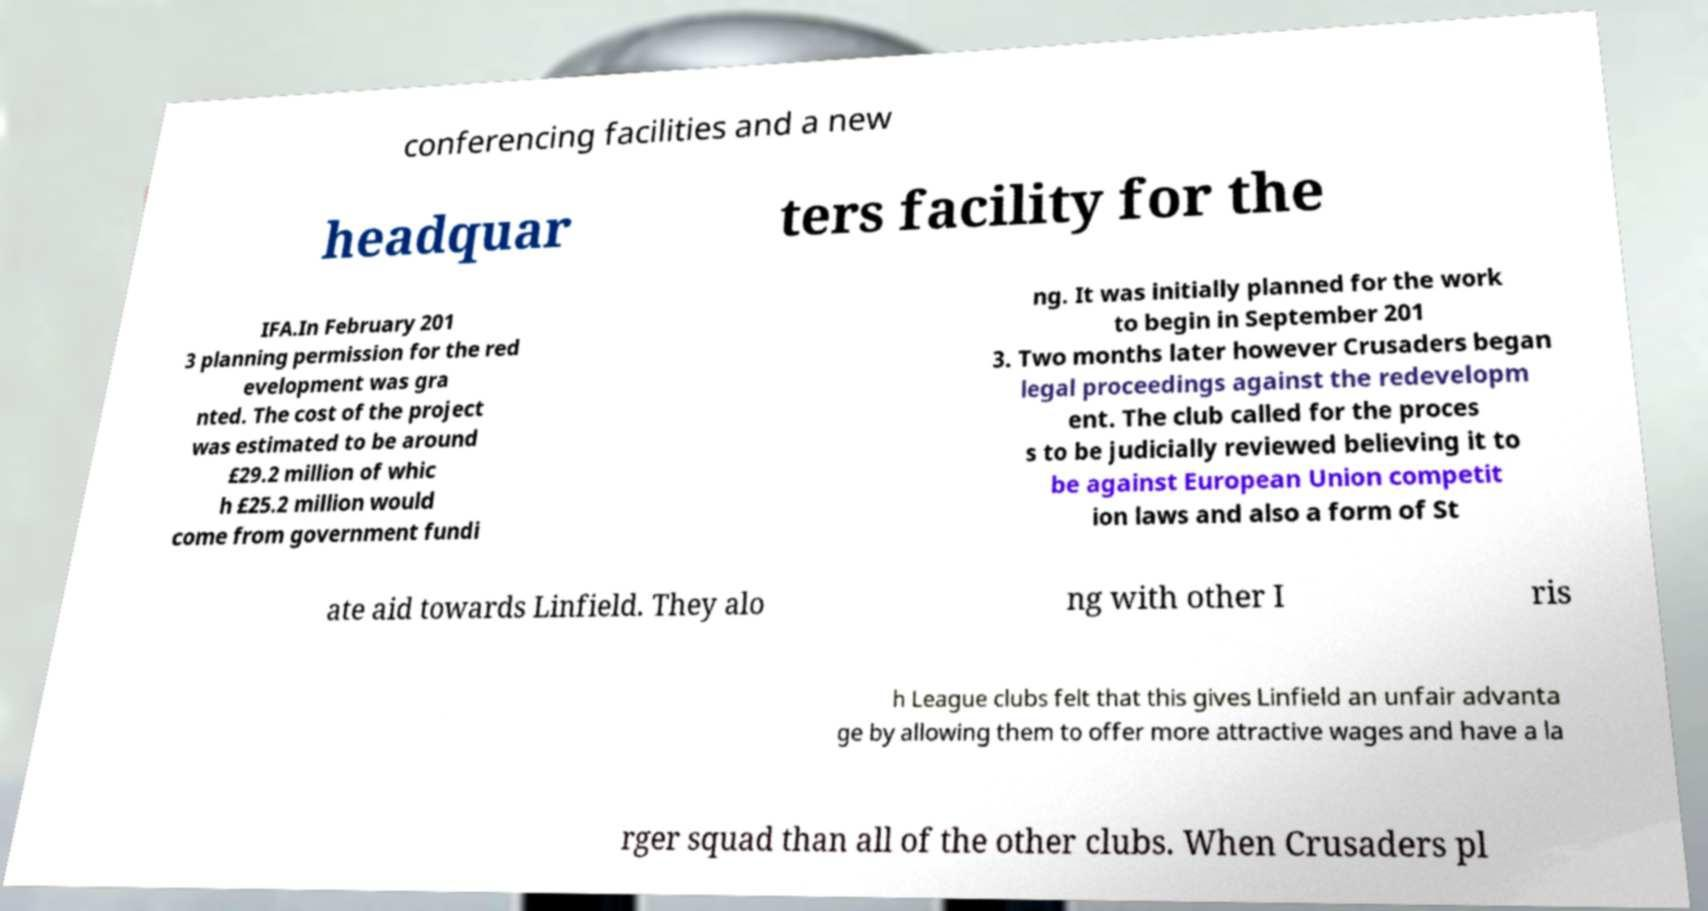I need the written content from this picture converted into text. Can you do that? conferencing facilities and a new headquar ters facility for the IFA.In February 201 3 planning permission for the red evelopment was gra nted. The cost of the project was estimated to be around £29.2 million of whic h £25.2 million would come from government fundi ng. It was initially planned for the work to begin in September 201 3. Two months later however Crusaders began legal proceedings against the redevelopm ent. The club called for the proces s to be judicially reviewed believing it to be against European Union competit ion laws and also a form of St ate aid towards Linfield. They alo ng with other I ris h League clubs felt that this gives Linfield an unfair advanta ge by allowing them to offer more attractive wages and have a la rger squad than all of the other clubs. When Crusaders pl 